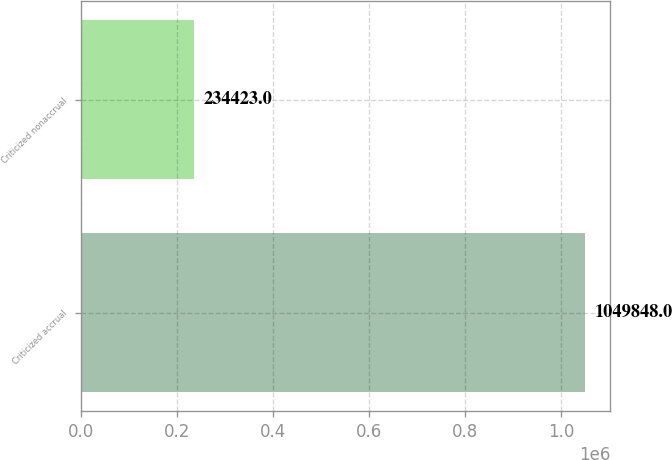<chart> <loc_0><loc_0><loc_500><loc_500><bar_chart><fcel>Criticized accrual<fcel>Criticized nonaccrual<nl><fcel>1.04985e+06<fcel>234423<nl></chart> 